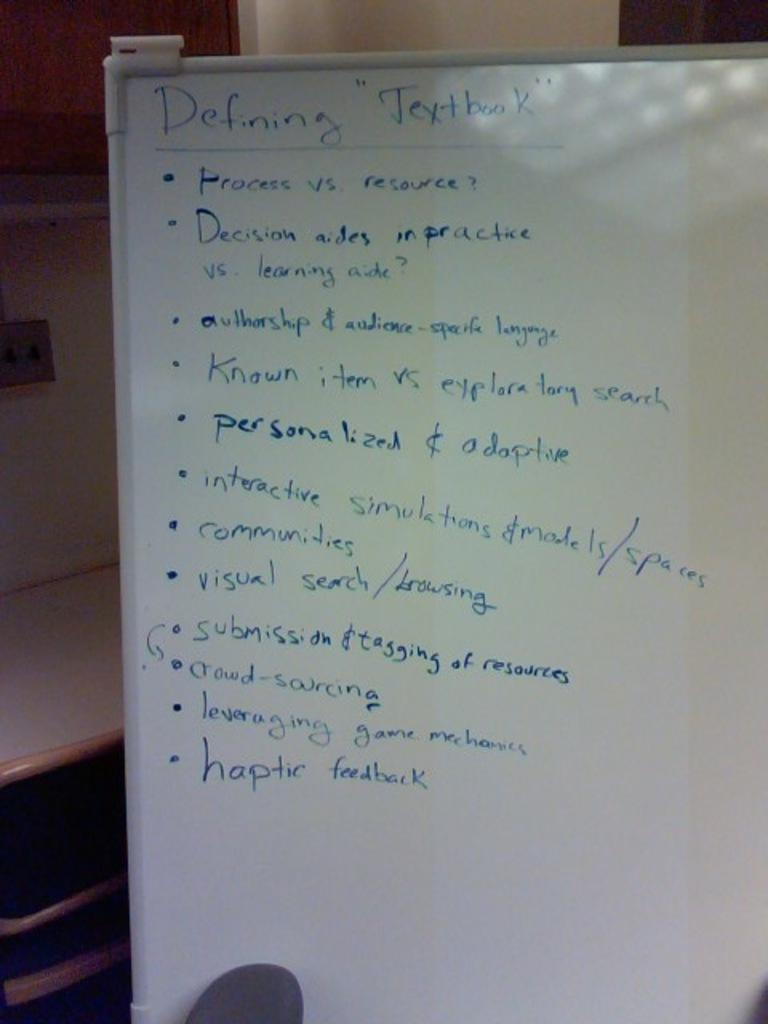<image>
Give a short and clear explanation of the subsequent image. A whiteboard that has notes written down under the headline of Defining Textbook. 